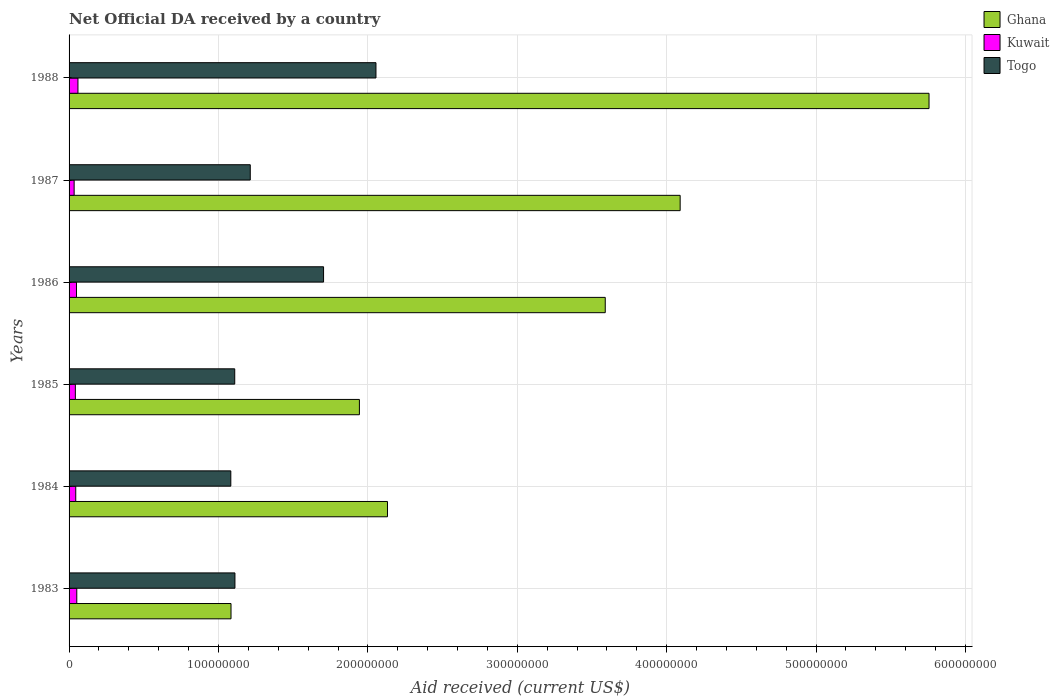How many different coloured bars are there?
Provide a succinct answer. 3. Are the number of bars per tick equal to the number of legend labels?
Give a very brief answer. Yes. How many bars are there on the 4th tick from the bottom?
Your answer should be very brief. 3. What is the label of the 1st group of bars from the top?
Keep it short and to the point. 1988. What is the net official development assistance aid received in Kuwait in 1983?
Your response must be concise. 5.16e+06. Across all years, what is the maximum net official development assistance aid received in Kuwait?
Make the answer very short. 5.94e+06. Across all years, what is the minimum net official development assistance aid received in Kuwait?
Offer a very short reply. 3.39e+06. In which year was the net official development assistance aid received in Ghana maximum?
Your answer should be compact. 1988. What is the total net official development assistance aid received in Togo in the graph?
Provide a succinct answer. 8.27e+08. What is the difference between the net official development assistance aid received in Ghana in 1983 and that in 1985?
Provide a short and direct response. -8.59e+07. What is the difference between the net official development assistance aid received in Ghana in 1988 and the net official development assistance aid received in Kuwait in 1986?
Keep it short and to the point. 5.71e+08. What is the average net official development assistance aid received in Ghana per year?
Ensure brevity in your answer.  3.10e+08. In the year 1984, what is the difference between the net official development assistance aid received in Togo and net official development assistance aid received in Kuwait?
Provide a short and direct response. 1.04e+08. What is the ratio of the net official development assistance aid received in Kuwait in 1985 to that in 1988?
Provide a short and direct response. 0.71. Is the difference between the net official development assistance aid received in Togo in 1984 and 1986 greater than the difference between the net official development assistance aid received in Kuwait in 1984 and 1986?
Offer a very short reply. No. What is the difference between the highest and the second highest net official development assistance aid received in Togo?
Offer a very short reply. 3.51e+07. What is the difference between the highest and the lowest net official development assistance aid received in Kuwait?
Your answer should be compact. 2.55e+06. In how many years, is the net official development assistance aid received in Ghana greater than the average net official development assistance aid received in Ghana taken over all years?
Offer a terse response. 3. What does the 1st bar from the top in 1987 represents?
Your answer should be very brief. Togo. What does the 1st bar from the bottom in 1988 represents?
Offer a very short reply. Ghana. Is it the case that in every year, the sum of the net official development assistance aid received in Togo and net official development assistance aid received in Ghana is greater than the net official development assistance aid received in Kuwait?
Give a very brief answer. Yes. How many bars are there?
Ensure brevity in your answer.  18. Are the values on the major ticks of X-axis written in scientific E-notation?
Your response must be concise. No. Does the graph contain grids?
Ensure brevity in your answer.  Yes. How many legend labels are there?
Your answer should be compact. 3. What is the title of the graph?
Make the answer very short. Net Official DA received by a country. Does "Comoros" appear as one of the legend labels in the graph?
Offer a terse response. No. What is the label or title of the X-axis?
Your answer should be compact. Aid received (current US$). What is the label or title of the Y-axis?
Give a very brief answer. Years. What is the Aid received (current US$) of Ghana in 1983?
Provide a succinct answer. 1.08e+08. What is the Aid received (current US$) of Kuwait in 1983?
Your answer should be compact. 5.16e+06. What is the Aid received (current US$) in Togo in 1983?
Provide a succinct answer. 1.11e+08. What is the Aid received (current US$) in Ghana in 1984?
Offer a terse response. 2.13e+08. What is the Aid received (current US$) of Kuwait in 1984?
Your answer should be compact. 4.47e+06. What is the Aid received (current US$) in Togo in 1984?
Your answer should be very brief. 1.08e+08. What is the Aid received (current US$) of Ghana in 1985?
Your answer should be very brief. 1.94e+08. What is the Aid received (current US$) of Kuwait in 1985?
Make the answer very short. 4.21e+06. What is the Aid received (current US$) of Togo in 1985?
Ensure brevity in your answer.  1.11e+08. What is the Aid received (current US$) of Ghana in 1986?
Your answer should be very brief. 3.59e+08. What is the Aid received (current US$) in Kuwait in 1986?
Keep it short and to the point. 4.96e+06. What is the Aid received (current US$) in Togo in 1986?
Your answer should be very brief. 1.70e+08. What is the Aid received (current US$) of Ghana in 1987?
Keep it short and to the point. 4.09e+08. What is the Aid received (current US$) in Kuwait in 1987?
Provide a succinct answer. 3.39e+06. What is the Aid received (current US$) of Togo in 1987?
Offer a terse response. 1.21e+08. What is the Aid received (current US$) in Ghana in 1988?
Your response must be concise. 5.76e+08. What is the Aid received (current US$) in Kuwait in 1988?
Give a very brief answer. 5.94e+06. What is the Aid received (current US$) of Togo in 1988?
Offer a very short reply. 2.05e+08. Across all years, what is the maximum Aid received (current US$) in Ghana?
Offer a very short reply. 5.76e+08. Across all years, what is the maximum Aid received (current US$) of Kuwait?
Ensure brevity in your answer.  5.94e+06. Across all years, what is the maximum Aid received (current US$) in Togo?
Your answer should be compact. 2.05e+08. Across all years, what is the minimum Aid received (current US$) in Ghana?
Offer a terse response. 1.08e+08. Across all years, what is the minimum Aid received (current US$) in Kuwait?
Offer a very short reply. 3.39e+06. Across all years, what is the minimum Aid received (current US$) in Togo?
Your answer should be compact. 1.08e+08. What is the total Aid received (current US$) in Ghana in the graph?
Provide a succinct answer. 1.86e+09. What is the total Aid received (current US$) in Kuwait in the graph?
Make the answer very short. 2.81e+07. What is the total Aid received (current US$) in Togo in the graph?
Give a very brief answer. 8.27e+08. What is the difference between the Aid received (current US$) of Ghana in 1983 and that in 1984?
Keep it short and to the point. -1.05e+08. What is the difference between the Aid received (current US$) in Kuwait in 1983 and that in 1984?
Provide a succinct answer. 6.90e+05. What is the difference between the Aid received (current US$) of Togo in 1983 and that in 1984?
Keep it short and to the point. 2.76e+06. What is the difference between the Aid received (current US$) of Ghana in 1983 and that in 1985?
Offer a very short reply. -8.59e+07. What is the difference between the Aid received (current US$) in Kuwait in 1983 and that in 1985?
Your response must be concise. 9.50e+05. What is the difference between the Aid received (current US$) of Ghana in 1983 and that in 1986?
Offer a very short reply. -2.50e+08. What is the difference between the Aid received (current US$) in Togo in 1983 and that in 1986?
Make the answer very short. -5.93e+07. What is the difference between the Aid received (current US$) in Ghana in 1983 and that in 1987?
Provide a short and direct response. -3.01e+08. What is the difference between the Aid received (current US$) in Kuwait in 1983 and that in 1987?
Offer a very short reply. 1.77e+06. What is the difference between the Aid received (current US$) of Togo in 1983 and that in 1987?
Give a very brief answer. -1.03e+07. What is the difference between the Aid received (current US$) of Ghana in 1983 and that in 1988?
Your answer should be compact. -4.67e+08. What is the difference between the Aid received (current US$) in Kuwait in 1983 and that in 1988?
Provide a short and direct response. -7.80e+05. What is the difference between the Aid received (current US$) in Togo in 1983 and that in 1988?
Give a very brief answer. -9.44e+07. What is the difference between the Aid received (current US$) in Ghana in 1984 and that in 1985?
Your response must be concise. 1.88e+07. What is the difference between the Aid received (current US$) in Togo in 1984 and that in 1985?
Give a very brief answer. -2.62e+06. What is the difference between the Aid received (current US$) of Ghana in 1984 and that in 1986?
Your answer should be very brief. -1.46e+08. What is the difference between the Aid received (current US$) in Kuwait in 1984 and that in 1986?
Provide a short and direct response. -4.90e+05. What is the difference between the Aid received (current US$) in Togo in 1984 and that in 1986?
Offer a very short reply. -6.21e+07. What is the difference between the Aid received (current US$) in Ghana in 1984 and that in 1987?
Your answer should be compact. -1.96e+08. What is the difference between the Aid received (current US$) in Kuwait in 1984 and that in 1987?
Your response must be concise. 1.08e+06. What is the difference between the Aid received (current US$) of Togo in 1984 and that in 1987?
Make the answer very short. -1.30e+07. What is the difference between the Aid received (current US$) of Ghana in 1984 and that in 1988?
Your answer should be compact. -3.62e+08. What is the difference between the Aid received (current US$) of Kuwait in 1984 and that in 1988?
Provide a short and direct response. -1.47e+06. What is the difference between the Aid received (current US$) of Togo in 1984 and that in 1988?
Your answer should be compact. -9.72e+07. What is the difference between the Aid received (current US$) in Ghana in 1985 and that in 1986?
Provide a succinct answer. -1.65e+08. What is the difference between the Aid received (current US$) in Kuwait in 1985 and that in 1986?
Provide a succinct answer. -7.50e+05. What is the difference between the Aid received (current US$) of Togo in 1985 and that in 1986?
Offer a terse response. -5.95e+07. What is the difference between the Aid received (current US$) in Ghana in 1985 and that in 1987?
Give a very brief answer. -2.15e+08. What is the difference between the Aid received (current US$) of Kuwait in 1985 and that in 1987?
Your answer should be compact. 8.20e+05. What is the difference between the Aid received (current US$) of Togo in 1985 and that in 1987?
Offer a very short reply. -1.04e+07. What is the difference between the Aid received (current US$) in Ghana in 1985 and that in 1988?
Give a very brief answer. -3.81e+08. What is the difference between the Aid received (current US$) in Kuwait in 1985 and that in 1988?
Offer a terse response. -1.73e+06. What is the difference between the Aid received (current US$) of Togo in 1985 and that in 1988?
Provide a short and direct response. -9.45e+07. What is the difference between the Aid received (current US$) in Ghana in 1986 and that in 1987?
Your answer should be very brief. -5.01e+07. What is the difference between the Aid received (current US$) of Kuwait in 1986 and that in 1987?
Offer a terse response. 1.57e+06. What is the difference between the Aid received (current US$) in Togo in 1986 and that in 1987?
Your answer should be compact. 4.91e+07. What is the difference between the Aid received (current US$) of Ghana in 1986 and that in 1988?
Your answer should be very brief. -2.17e+08. What is the difference between the Aid received (current US$) of Kuwait in 1986 and that in 1988?
Offer a very short reply. -9.80e+05. What is the difference between the Aid received (current US$) of Togo in 1986 and that in 1988?
Provide a succinct answer. -3.51e+07. What is the difference between the Aid received (current US$) in Ghana in 1987 and that in 1988?
Make the answer very short. -1.67e+08. What is the difference between the Aid received (current US$) of Kuwait in 1987 and that in 1988?
Provide a succinct answer. -2.55e+06. What is the difference between the Aid received (current US$) of Togo in 1987 and that in 1988?
Ensure brevity in your answer.  -8.41e+07. What is the difference between the Aid received (current US$) in Ghana in 1983 and the Aid received (current US$) in Kuwait in 1984?
Ensure brevity in your answer.  1.04e+08. What is the difference between the Aid received (current US$) in Kuwait in 1983 and the Aid received (current US$) in Togo in 1984?
Provide a succinct answer. -1.03e+08. What is the difference between the Aid received (current US$) of Ghana in 1983 and the Aid received (current US$) of Kuwait in 1985?
Provide a short and direct response. 1.04e+08. What is the difference between the Aid received (current US$) in Ghana in 1983 and the Aid received (current US$) in Togo in 1985?
Give a very brief answer. -2.49e+06. What is the difference between the Aid received (current US$) in Kuwait in 1983 and the Aid received (current US$) in Togo in 1985?
Offer a terse response. -1.06e+08. What is the difference between the Aid received (current US$) in Ghana in 1983 and the Aid received (current US$) in Kuwait in 1986?
Offer a terse response. 1.03e+08. What is the difference between the Aid received (current US$) in Ghana in 1983 and the Aid received (current US$) in Togo in 1986?
Your answer should be compact. -6.20e+07. What is the difference between the Aid received (current US$) of Kuwait in 1983 and the Aid received (current US$) of Togo in 1986?
Your answer should be very brief. -1.65e+08. What is the difference between the Aid received (current US$) in Ghana in 1983 and the Aid received (current US$) in Kuwait in 1987?
Ensure brevity in your answer.  1.05e+08. What is the difference between the Aid received (current US$) of Ghana in 1983 and the Aid received (current US$) of Togo in 1987?
Provide a succinct answer. -1.29e+07. What is the difference between the Aid received (current US$) of Kuwait in 1983 and the Aid received (current US$) of Togo in 1987?
Offer a terse response. -1.16e+08. What is the difference between the Aid received (current US$) of Ghana in 1983 and the Aid received (current US$) of Kuwait in 1988?
Offer a terse response. 1.02e+08. What is the difference between the Aid received (current US$) in Ghana in 1983 and the Aid received (current US$) in Togo in 1988?
Your answer should be compact. -9.70e+07. What is the difference between the Aid received (current US$) in Kuwait in 1983 and the Aid received (current US$) in Togo in 1988?
Give a very brief answer. -2.00e+08. What is the difference between the Aid received (current US$) of Ghana in 1984 and the Aid received (current US$) of Kuwait in 1985?
Provide a short and direct response. 2.09e+08. What is the difference between the Aid received (current US$) of Ghana in 1984 and the Aid received (current US$) of Togo in 1985?
Provide a short and direct response. 1.02e+08. What is the difference between the Aid received (current US$) of Kuwait in 1984 and the Aid received (current US$) of Togo in 1985?
Your answer should be compact. -1.06e+08. What is the difference between the Aid received (current US$) in Ghana in 1984 and the Aid received (current US$) in Kuwait in 1986?
Keep it short and to the point. 2.08e+08. What is the difference between the Aid received (current US$) of Ghana in 1984 and the Aid received (current US$) of Togo in 1986?
Provide a short and direct response. 4.28e+07. What is the difference between the Aid received (current US$) in Kuwait in 1984 and the Aid received (current US$) in Togo in 1986?
Ensure brevity in your answer.  -1.66e+08. What is the difference between the Aid received (current US$) in Ghana in 1984 and the Aid received (current US$) in Kuwait in 1987?
Provide a short and direct response. 2.10e+08. What is the difference between the Aid received (current US$) in Ghana in 1984 and the Aid received (current US$) in Togo in 1987?
Provide a succinct answer. 9.18e+07. What is the difference between the Aid received (current US$) of Kuwait in 1984 and the Aid received (current US$) of Togo in 1987?
Provide a short and direct response. -1.17e+08. What is the difference between the Aid received (current US$) of Ghana in 1984 and the Aid received (current US$) of Kuwait in 1988?
Provide a succinct answer. 2.07e+08. What is the difference between the Aid received (current US$) of Ghana in 1984 and the Aid received (current US$) of Togo in 1988?
Make the answer very short. 7.71e+06. What is the difference between the Aid received (current US$) of Kuwait in 1984 and the Aid received (current US$) of Togo in 1988?
Provide a succinct answer. -2.01e+08. What is the difference between the Aid received (current US$) in Ghana in 1985 and the Aid received (current US$) in Kuwait in 1986?
Your answer should be compact. 1.89e+08. What is the difference between the Aid received (current US$) of Ghana in 1985 and the Aid received (current US$) of Togo in 1986?
Ensure brevity in your answer.  2.40e+07. What is the difference between the Aid received (current US$) of Kuwait in 1985 and the Aid received (current US$) of Togo in 1986?
Offer a very short reply. -1.66e+08. What is the difference between the Aid received (current US$) in Ghana in 1985 and the Aid received (current US$) in Kuwait in 1987?
Ensure brevity in your answer.  1.91e+08. What is the difference between the Aid received (current US$) in Ghana in 1985 and the Aid received (current US$) in Togo in 1987?
Provide a succinct answer. 7.30e+07. What is the difference between the Aid received (current US$) of Kuwait in 1985 and the Aid received (current US$) of Togo in 1987?
Ensure brevity in your answer.  -1.17e+08. What is the difference between the Aid received (current US$) of Ghana in 1985 and the Aid received (current US$) of Kuwait in 1988?
Keep it short and to the point. 1.88e+08. What is the difference between the Aid received (current US$) in Ghana in 1985 and the Aid received (current US$) in Togo in 1988?
Ensure brevity in your answer.  -1.11e+07. What is the difference between the Aid received (current US$) of Kuwait in 1985 and the Aid received (current US$) of Togo in 1988?
Your answer should be very brief. -2.01e+08. What is the difference between the Aid received (current US$) of Ghana in 1986 and the Aid received (current US$) of Kuwait in 1987?
Your answer should be very brief. 3.55e+08. What is the difference between the Aid received (current US$) in Ghana in 1986 and the Aid received (current US$) in Togo in 1987?
Keep it short and to the point. 2.38e+08. What is the difference between the Aid received (current US$) of Kuwait in 1986 and the Aid received (current US$) of Togo in 1987?
Offer a very short reply. -1.16e+08. What is the difference between the Aid received (current US$) in Ghana in 1986 and the Aid received (current US$) in Kuwait in 1988?
Ensure brevity in your answer.  3.53e+08. What is the difference between the Aid received (current US$) of Ghana in 1986 and the Aid received (current US$) of Togo in 1988?
Provide a succinct answer. 1.53e+08. What is the difference between the Aid received (current US$) in Kuwait in 1986 and the Aid received (current US$) in Togo in 1988?
Keep it short and to the point. -2.00e+08. What is the difference between the Aid received (current US$) of Ghana in 1987 and the Aid received (current US$) of Kuwait in 1988?
Ensure brevity in your answer.  4.03e+08. What is the difference between the Aid received (current US$) of Ghana in 1987 and the Aid received (current US$) of Togo in 1988?
Your response must be concise. 2.04e+08. What is the difference between the Aid received (current US$) of Kuwait in 1987 and the Aid received (current US$) of Togo in 1988?
Give a very brief answer. -2.02e+08. What is the average Aid received (current US$) of Ghana per year?
Provide a succinct answer. 3.10e+08. What is the average Aid received (current US$) of Kuwait per year?
Offer a terse response. 4.69e+06. What is the average Aid received (current US$) of Togo per year?
Offer a terse response. 1.38e+08. In the year 1983, what is the difference between the Aid received (current US$) in Ghana and Aid received (current US$) in Kuwait?
Your response must be concise. 1.03e+08. In the year 1983, what is the difference between the Aid received (current US$) of Ghana and Aid received (current US$) of Togo?
Offer a terse response. -2.63e+06. In the year 1983, what is the difference between the Aid received (current US$) in Kuwait and Aid received (current US$) in Togo?
Your response must be concise. -1.06e+08. In the year 1984, what is the difference between the Aid received (current US$) of Ghana and Aid received (current US$) of Kuwait?
Provide a short and direct response. 2.09e+08. In the year 1984, what is the difference between the Aid received (current US$) of Ghana and Aid received (current US$) of Togo?
Your answer should be compact. 1.05e+08. In the year 1984, what is the difference between the Aid received (current US$) of Kuwait and Aid received (current US$) of Togo?
Make the answer very short. -1.04e+08. In the year 1985, what is the difference between the Aid received (current US$) in Ghana and Aid received (current US$) in Kuwait?
Ensure brevity in your answer.  1.90e+08. In the year 1985, what is the difference between the Aid received (current US$) in Ghana and Aid received (current US$) in Togo?
Provide a succinct answer. 8.34e+07. In the year 1985, what is the difference between the Aid received (current US$) of Kuwait and Aid received (current US$) of Togo?
Provide a succinct answer. -1.07e+08. In the year 1986, what is the difference between the Aid received (current US$) of Ghana and Aid received (current US$) of Kuwait?
Give a very brief answer. 3.54e+08. In the year 1986, what is the difference between the Aid received (current US$) in Ghana and Aid received (current US$) in Togo?
Provide a short and direct response. 1.89e+08. In the year 1986, what is the difference between the Aid received (current US$) of Kuwait and Aid received (current US$) of Togo?
Give a very brief answer. -1.65e+08. In the year 1987, what is the difference between the Aid received (current US$) in Ghana and Aid received (current US$) in Kuwait?
Your response must be concise. 4.06e+08. In the year 1987, what is the difference between the Aid received (current US$) of Ghana and Aid received (current US$) of Togo?
Keep it short and to the point. 2.88e+08. In the year 1987, what is the difference between the Aid received (current US$) of Kuwait and Aid received (current US$) of Togo?
Provide a short and direct response. -1.18e+08. In the year 1988, what is the difference between the Aid received (current US$) in Ghana and Aid received (current US$) in Kuwait?
Give a very brief answer. 5.70e+08. In the year 1988, what is the difference between the Aid received (current US$) in Ghana and Aid received (current US$) in Togo?
Offer a very short reply. 3.70e+08. In the year 1988, what is the difference between the Aid received (current US$) of Kuwait and Aid received (current US$) of Togo?
Your answer should be compact. -1.99e+08. What is the ratio of the Aid received (current US$) in Ghana in 1983 to that in 1984?
Provide a short and direct response. 0.51. What is the ratio of the Aid received (current US$) in Kuwait in 1983 to that in 1984?
Provide a short and direct response. 1.15. What is the ratio of the Aid received (current US$) of Togo in 1983 to that in 1984?
Give a very brief answer. 1.03. What is the ratio of the Aid received (current US$) in Ghana in 1983 to that in 1985?
Offer a very short reply. 0.56. What is the ratio of the Aid received (current US$) of Kuwait in 1983 to that in 1985?
Ensure brevity in your answer.  1.23. What is the ratio of the Aid received (current US$) of Ghana in 1983 to that in 1986?
Give a very brief answer. 0.3. What is the ratio of the Aid received (current US$) in Kuwait in 1983 to that in 1986?
Keep it short and to the point. 1.04. What is the ratio of the Aid received (current US$) of Togo in 1983 to that in 1986?
Your response must be concise. 0.65. What is the ratio of the Aid received (current US$) in Ghana in 1983 to that in 1987?
Make the answer very short. 0.27. What is the ratio of the Aid received (current US$) of Kuwait in 1983 to that in 1987?
Provide a succinct answer. 1.52. What is the ratio of the Aid received (current US$) of Togo in 1983 to that in 1987?
Offer a terse response. 0.92. What is the ratio of the Aid received (current US$) in Ghana in 1983 to that in 1988?
Keep it short and to the point. 0.19. What is the ratio of the Aid received (current US$) in Kuwait in 1983 to that in 1988?
Offer a very short reply. 0.87. What is the ratio of the Aid received (current US$) in Togo in 1983 to that in 1988?
Your answer should be very brief. 0.54. What is the ratio of the Aid received (current US$) in Ghana in 1984 to that in 1985?
Provide a succinct answer. 1.1. What is the ratio of the Aid received (current US$) of Kuwait in 1984 to that in 1985?
Ensure brevity in your answer.  1.06. What is the ratio of the Aid received (current US$) in Togo in 1984 to that in 1985?
Keep it short and to the point. 0.98. What is the ratio of the Aid received (current US$) of Ghana in 1984 to that in 1986?
Provide a short and direct response. 0.59. What is the ratio of the Aid received (current US$) of Kuwait in 1984 to that in 1986?
Your response must be concise. 0.9. What is the ratio of the Aid received (current US$) in Togo in 1984 to that in 1986?
Keep it short and to the point. 0.64. What is the ratio of the Aid received (current US$) of Ghana in 1984 to that in 1987?
Offer a terse response. 0.52. What is the ratio of the Aid received (current US$) in Kuwait in 1984 to that in 1987?
Your response must be concise. 1.32. What is the ratio of the Aid received (current US$) in Togo in 1984 to that in 1987?
Give a very brief answer. 0.89. What is the ratio of the Aid received (current US$) of Ghana in 1984 to that in 1988?
Your answer should be compact. 0.37. What is the ratio of the Aid received (current US$) in Kuwait in 1984 to that in 1988?
Offer a very short reply. 0.75. What is the ratio of the Aid received (current US$) of Togo in 1984 to that in 1988?
Give a very brief answer. 0.53. What is the ratio of the Aid received (current US$) of Ghana in 1985 to that in 1986?
Your response must be concise. 0.54. What is the ratio of the Aid received (current US$) in Kuwait in 1985 to that in 1986?
Offer a very short reply. 0.85. What is the ratio of the Aid received (current US$) of Togo in 1985 to that in 1986?
Make the answer very short. 0.65. What is the ratio of the Aid received (current US$) of Ghana in 1985 to that in 1987?
Offer a very short reply. 0.48. What is the ratio of the Aid received (current US$) in Kuwait in 1985 to that in 1987?
Ensure brevity in your answer.  1.24. What is the ratio of the Aid received (current US$) in Togo in 1985 to that in 1987?
Give a very brief answer. 0.91. What is the ratio of the Aid received (current US$) in Ghana in 1985 to that in 1988?
Offer a very short reply. 0.34. What is the ratio of the Aid received (current US$) of Kuwait in 1985 to that in 1988?
Your response must be concise. 0.71. What is the ratio of the Aid received (current US$) of Togo in 1985 to that in 1988?
Your answer should be very brief. 0.54. What is the ratio of the Aid received (current US$) in Ghana in 1986 to that in 1987?
Offer a terse response. 0.88. What is the ratio of the Aid received (current US$) in Kuwait in 1986 to that in 1987?
Your answer should be compact. 1.46. What is the ratio of the Aid received (current US$) in Togo in 1986 to that in 1987?
Provide a short and direct response. 1.4. What is the ratio of the Aid received (current US$) of Ghana in 1986 to that in 1988?
Provide a succinct answer. 0.62. What is the ratio of the Aid received (current US$) in Kuwait in 1986 to that in 1988?
Your answer should be compact. 0.83. What is the ratio of the Aid received (current US$) in Togo in 1986 to that in 1988?
Make the answer very short. 0.83. What is the ratio of the Aid received (current US$) of Ghana in 1987 to that in 1988?
Keep it short and to the point. 0.71. What is the ratio of the Aid received (current US$) in Kuwait in 1987 to that in 1988?
Keep it short and to the point. 0.57. What is the ratio of the Aid received (current US$) in Togo in 1987 to that in 1988?
Offer a terse response. 0.59. What is the difference between the highest and the second highest Aid received (current US$) in Ghana?
Offer a very short reply. 1.67e+08. What is the difference between the highest and the second highest Aid received (current US$) of Kuwait?
Provide a short and direct response. 7.80e+05. What is the difference between the highest and the second highest Aid received (current US$) in Togo?
Your answer should be very brief. 3.51e+07. What is the difference between the highest and the lowest Aid received (current US$) of Ghana?
Your answer should be compact. 4.67e+08. What is the difference between the highest and the lowest Aid received (current US$) of Kuwait?
Provide a succinct answer. 2.55e+06. What is the difference between the highest and the lowest Aid received (current US$) in Togo?
Offer a very short reply. 9.72e+07. 